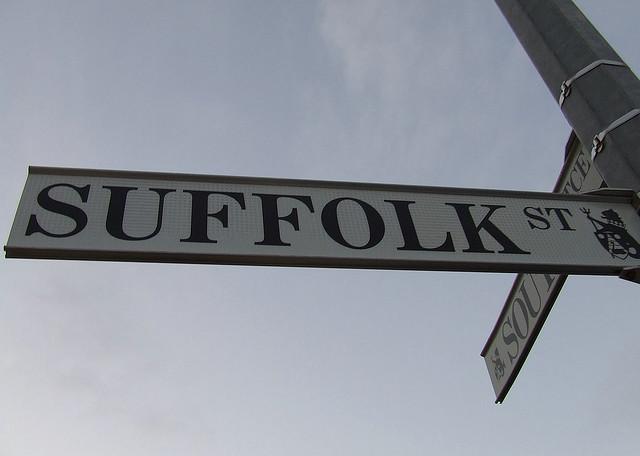What is the first letter of the street name?
Write a very short answer. S. How many signs are on the post?
Keep it brief. 2. Are there four signs on a pole?
Write a very short answer. No. North, south, east, or west?
Quick response, please. South. Which street is been shown?
Keep it brief. Suffolk. What is the name of the street sign?
Quick response, please. Suffolk st. 